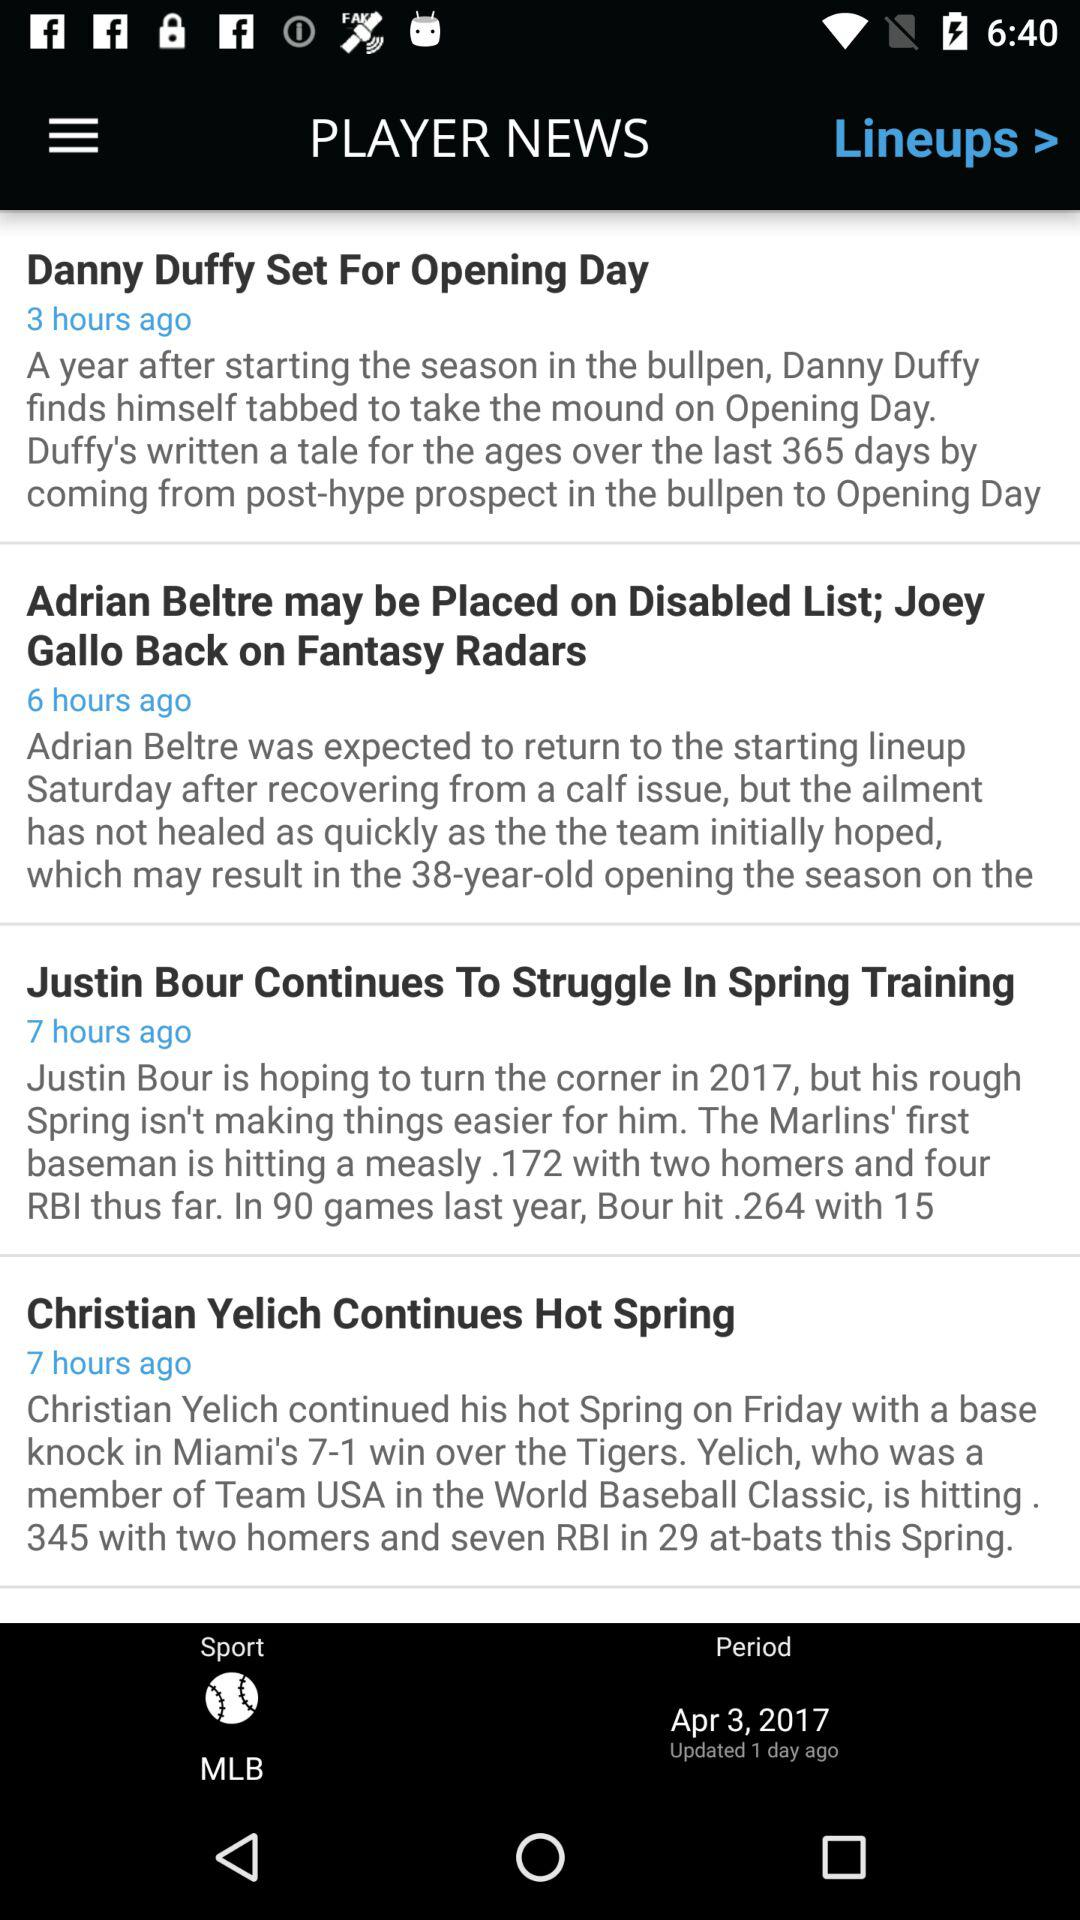When was the news "Christian Yelich Continues Hot Spring" published? The news was published 7 hours ago. 